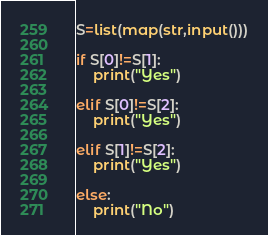<code> <loc_0><loc_0><loc_500><loc_500><_Python_>S=list(map(str,input()))

if S[0]!=S[1]:
    print("Yes")

elif S[0]!=S[2]:
    print("Yes")

elif S[1]!=S[2]:
    print("Yes")

else:
    print("No")</code> 